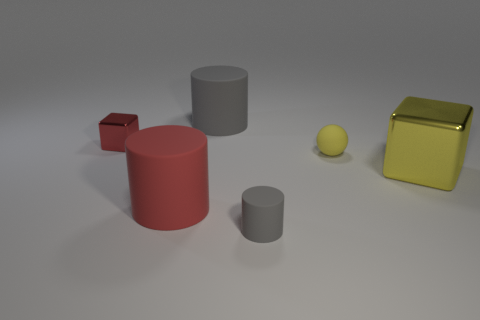Do the small rubber sphere and the block to the right of the matte sphere have the same color?
Provide a succinct answer. Yes. What is the color of the small cylinder on the right side of the gray thing that is behind the metal cube left of the big gray thing?
Provide a succinct answer. Gray. There is another shiny object that is the same shape as the yellow shiny thing; what color is it?
Ensure brevity in your answer.  Red. Are there the same number of large gray cylinders in front of the small cylinder and red matte cubes?
Offer a terse response. Yes. How many cylinders are either green shiny things or big red objects?
Ensure brevity in your answer.  1. What color is the tiny ball that is made of the same material as the red cylinder?
Give a very brief answer. Yellow. Is the big gray cylinder made of the same material as the big cylinder in front of the tiny matte ball?
Offer a very short reply. Yes. What number of objects are either cylinders or red metallic blocks?
Ensure brevity in your answer.  4. What material is the big thing that is the same color as the small metal block?
Ensure brevity in your answer.  Rubber. Is there another large yellow object that has the same shape as the large yellow object?
Offer a very short reply. No. 